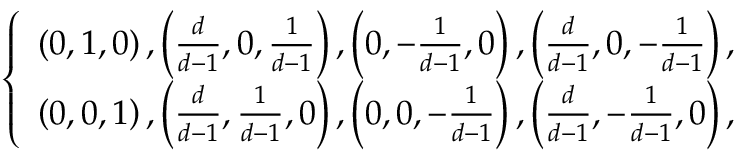<formula> <loc_0><loc_0><loc_500><loc_500>\left \{ \begin{array} { l l l } { \left ( 0 , 1 , 0 \right ) , \left ( \frac { d } { d - 1 } , 0 , \frac { 1 } { d - 1 } \right ) , \left ( 0 , - \frac { 1 } { d - 1 } , 0 \right ) , \left ( \frac { d } { d - 1 } , 0 , - \frac { 1 } { d - 1 } \right ) , } \\ { \left ( 0 , 0 , 1 \right ) , \left ( \frac { d } { d - 1 } , \frac { 1 } { d - 1 } , 0 \right ) , \left ( 0 , 0 , - \frac { 1 } { d - 1 } \right ) , \left ( \frac { d } { d - 1 } , - \frac { 1 } { d - 1 } , 0 \right ) , } \end{array}</formula> 